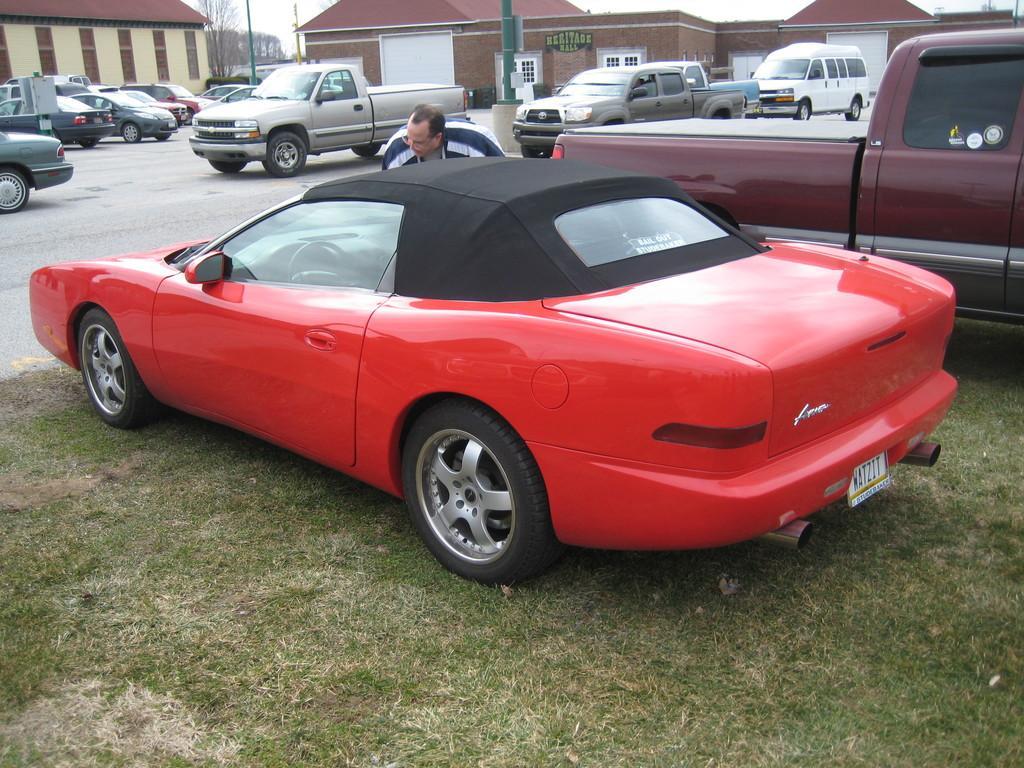Can you describe this image briefly? In this image there is a road, on the road there are some vehicles, person, pole, houses, tree, there is the sky at the top. 